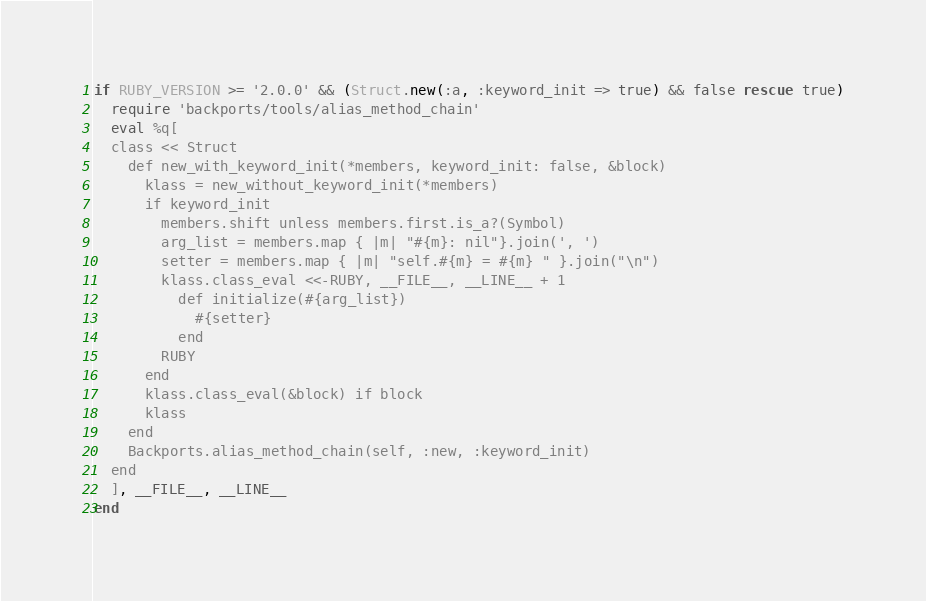Convert code to text. <code><loc_0><loc_0><loc_500><loc_500><_Ruby_>if RUBY_VERSION >= '2.0.0' && (Struct.new(:a, :keyword_init => true) && false rescue true)
  require 'backports/tools/alias_method_chain'
  eval %q[
  class << Struct
    def new_with_keyword_init(*members, keyword_init: false, &block)
      klass = new_without_keyword_init(*members)
      if keyword_init
        members.shift unless members.first.is_a?(Symbol)
        arg_list = members.map { |m| "#{m}: nil"}.join(', ')
        setter = members.map { |m| "self.#{m} = #{m} " }.join("\n")
        klass.class_eval <<-RUBY, __FILE__, __LINE__ + 1
          def initialize(#{arg_list})
            #{setter}
          end
        RUBY
      end
      klass.class_eval(&block) if block
      klass
    end
    Backports.alias_method_chain(self, :new, :keyword_init)
  end
  ], __FILE__, __LINE__
end
</code> 